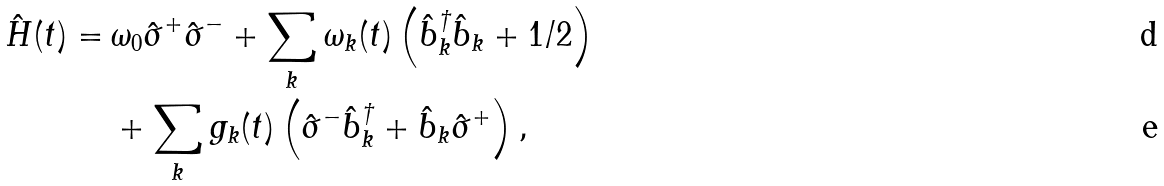Convert formula to latex. <formula><loc_0><loc_0><loc_500><loc_500>\hat { H } ( t ) = \, & \omega _ { 0 } \hat { \sigma } ^ { + } \hat { \sigma } ^ { - } + \sum _ { k } \omega _ { k } ( t ) \left ( \hat { b } _ { k } ^ { \dagger } \hat { b } _ { k } + 1 / 2 \right ) \\ & + \sum _ { k } g _ { k } ( t ) \left ( \hat { \sigma } ^ { - } \hat { b } _ { k } ^ { \dagger } + \hat { b } _ { k } \hat { \sigma } ^ { + } \right ) ,</formula> 